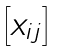Convert formula to latex. <formula><loc_0><loc_0><loc_500><loc_500>\begin{bmatrix} x _ { i j } \end{bmatrix}</formula> 